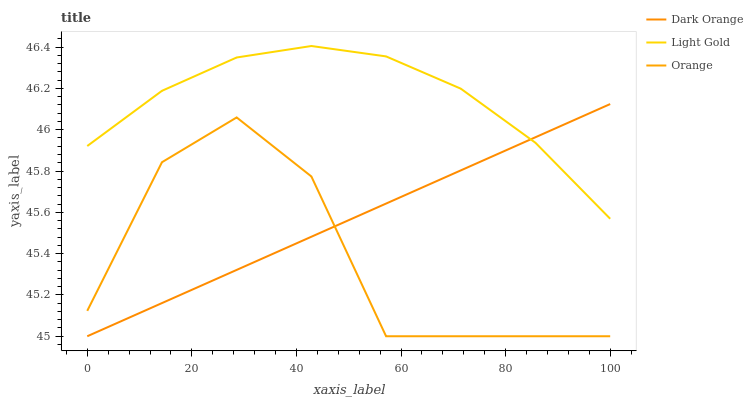Does Orange have the minimum area under the curve?
Answer yes or no. Yes. Does Light Gold have the maximum area under the curve?
Answer yes or no. Yes. Does Dark Orange have the minimum area under the curve?
Answer yes or no. No. Does Dark Orange have the maximum area under the curve?
Answer yes or no. No. Is Dark Orange the smoothest?
Answer yes or no. Yes. Is Orange the roughest?
Answer yes or no. Yes. Is Light Gold the smoothest?
Answer yes or no. No. Is Light Gold the roughest?
Answer yes or no. No. Does Light Gold have the lowest value?
Answer yes or no. No. Does Dark Orange have the highest value?
Answer yes or no. No. Is Orange less than Light Gold?
Answer yes or no. Yes. Is Light Gold greater than Orange?
Answer yes or no. Yes. Does Orange intersect Light Gold?
Answer yes or no. No. 